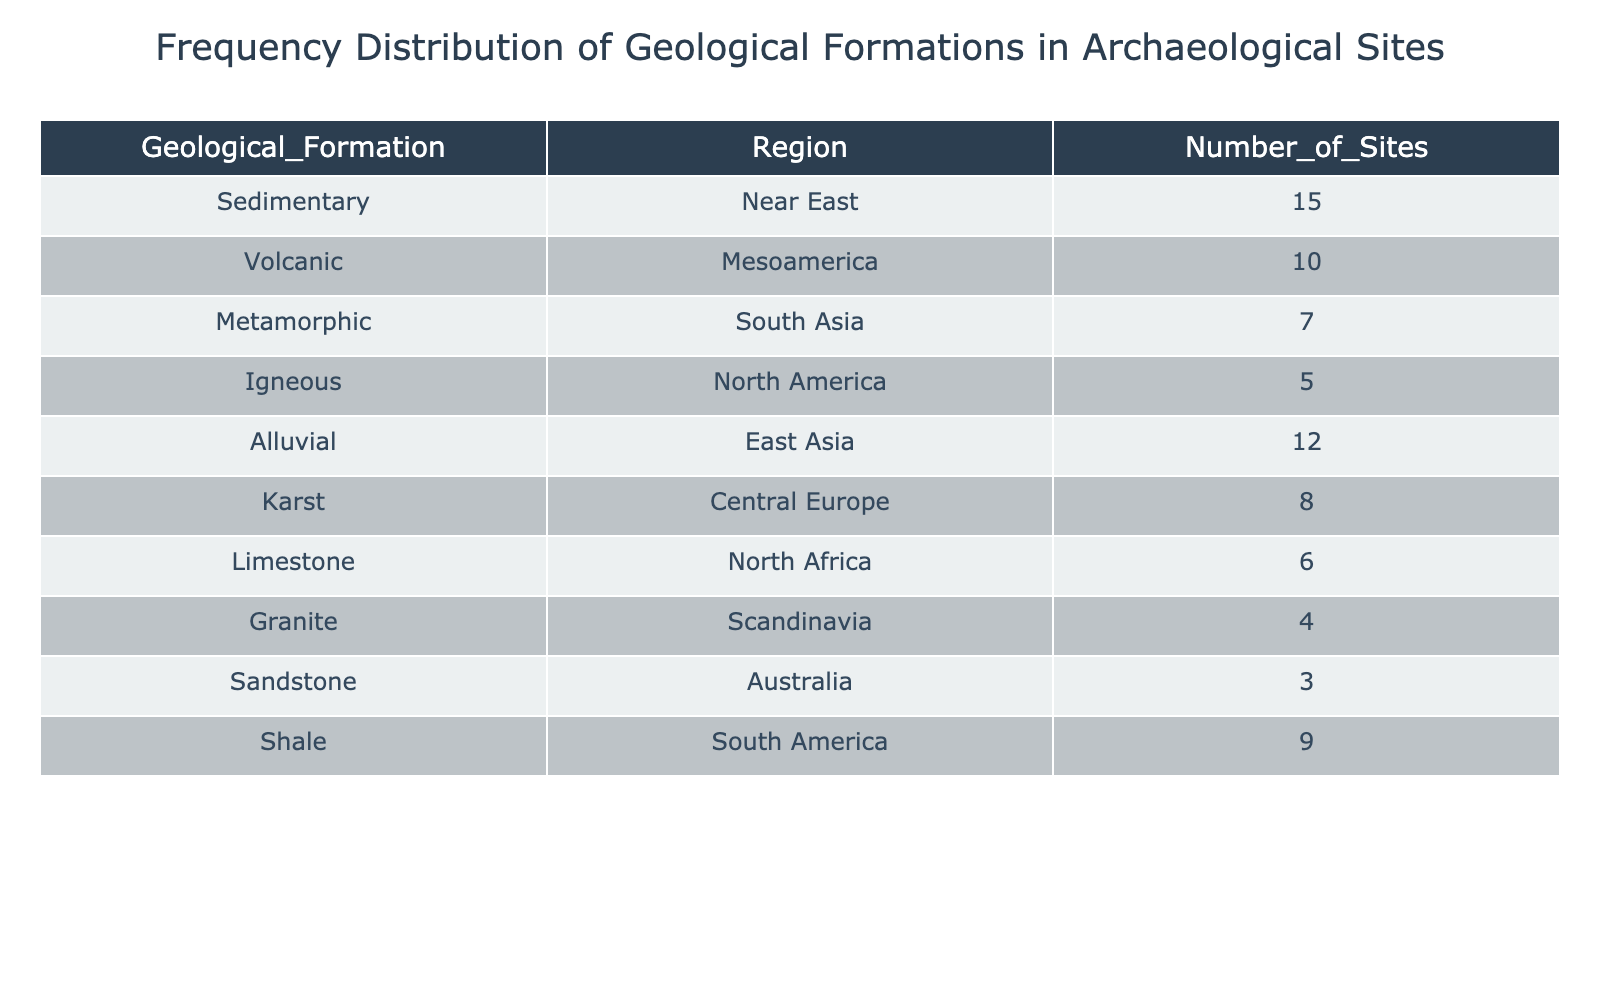What is the most common type of geological formation found in archaeological sites? By looking at the "Number_of_Sites" column, we can find the largest number associated with a geological formation. The highest number is 15, which corresponds to the "Sedimentary" formation in the "Near East" region.
Answer: Sedimentary Which geological formations are found in South Asia and their corresponding number of sites? In the table, by identifying the geological formation for South Asia, we find "Metamorphic" listed, with a corresponding number of sites of 7.
Answer: Metamorphic, 7 What is the total number of archaeological sites recorded in the regions with Alluvial formations? There is only one entry for Alluvial in the "East Asia" region, which has a total of 12 sites. Therefore, the total is 12.
Answer: 12 Are there more archaeological sites in North America than in Scandinavia? North America has 5 sites (Igneous), and Scandinavia has 4 (Granite). Comparing these two values, North America has 5, which is greater than 4.
Answer: Yes Calculate the average number of sites for the geological formations listed in the table. First, we add up all the "Number_of_Sites": (15 + 10 + 7 + 5 + 12 + 8 + 6 + 4 + 3 + 9) = 69. There are 10 geological formations, so we divide 69 by 10, resulting in an average of 6.9.
Answer: 6.9 How many total sites are there in regions with Limestone and Karst formations combined? Limestone is found in North Africa with 6 sites, and Karst is in Central Europe with 8 sites. Adding these numbers together, 6 + 8 gives us a total of 14 sites.
Answer: 14 Is there any geological formation with less than 5 sites listed in the table? Checking each "Number_of_Sites," we find that Sandstone in Australia has 3 sites, which is less than 5. Therefore, the answer is yes.
Answer: Yes Which region has the highest number of archaeological sites, and what geological formation is it associated with? The Near East region has the highest number of sites, with 15 associated with the Sedimentary formation.
Answer: Near East, Sedimentary What is the difference in the number of sites between the Volcanic formation and the Shale formation? There are 10 sites for Volcanic in Mesoamerica and 9 sites for Shale in South America. The difference is 10 - 9, which equals 1.
Answer: 1 